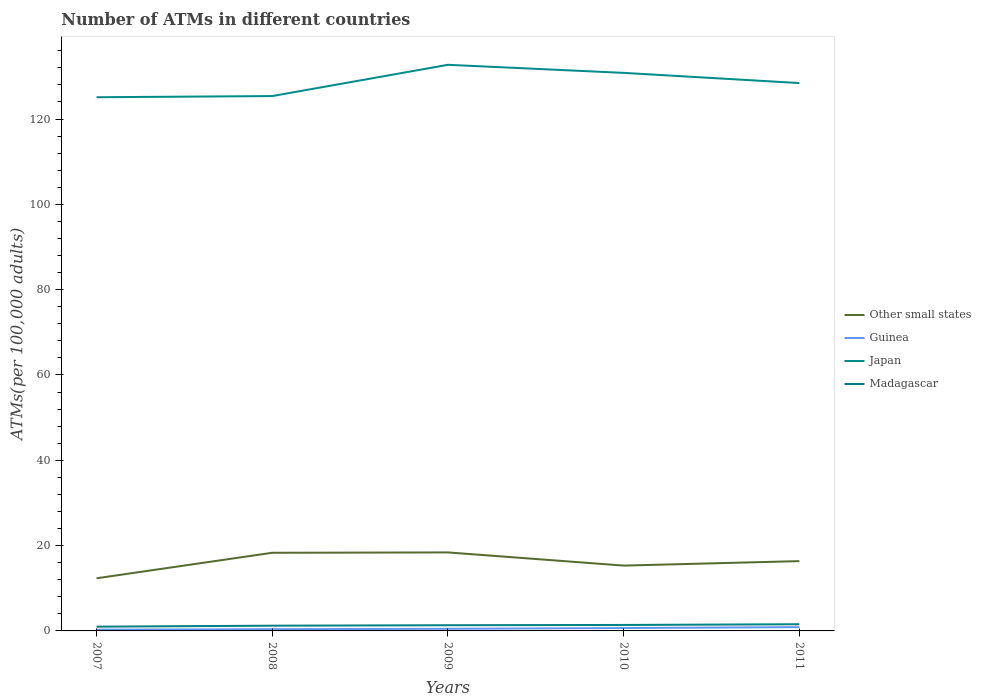How many different coloured lines are there?
Give a very brief answer. 4. Does the line corresponding to Other small states intersect with the line corresponding to Madagascar?
Offer a terse response. No. Across all years, what is the maximum number of ATMs in Other small states?
Provide a succinct answer. 12.34. What is the total number of ATMs in Guinea in the graph?
Offer a terse response. -0.38. What is the difference between the highest and the second highest number of ATMs in Guinea?
Provide a short and direct response. 0.59. What is the difference between two consecutive major ticks on the Y-axis?
Keep it short and to the point. 20. Does the graph contain any zero values?
Offer a terse response. No. Does the graph contain grids?
Give a very brief answer. No. Where does the legend appear in the graph?
Your answer should be very brief. Center right. How many legend labels are there?
Provide a short and direct response. 4. How are the legend labels stacked?
Give a very brief answer. Vertical. What is the title of the graph?
Offer a terse response. Number of ATMs in different countries. What is the label or title of the Y-axis?
Your response must be concise. ATMs(per 100,0 adults). What is the ATMs(per 100,000 adults) of Other small states in 2007?
Your answer should be compact. 12.34. What is the ATMs(per 100,000 adults) in Guinea in 2007?
Your answer should be compact. 0.3. What is the ATMs(per 100,000 adults) of Japan in 2007?
Ensure brevity in your answer.  125.11. What is the ATMs(per 100,000 adults) in Madagascar in 2007?
Give a very brief answer. 1. What is the ATMs(per 100,000 adults) in Other small states in 2008?
Your answer should be very brief. 18.32. What is the ATMs(per 100,000 adults) of Guinea in 2008?
Give a very brief answer. 0.41. What is the ATMs(per 100,000 adults) in Japan in 2008?
Offer a very short reply. 125.39. What is the ATMs(per 100,000 adults) in Madagascar in 2008?
Make the answer very short. 1.23. What is the ATMs(per 100,000 adults) in Other small states in 2009?
Make the answer very short. 18.4. What is the ATMs(per 100,000 adults) of Guinea in 2009?
Keep it short and to the point. 0.5. What is the ATMs(per 100,000 adults) in Japan in 2009?
Your response must be concise. 132.71. What is the ATMs(per 100,000 adults) of Madagascar in 2009?
Give a very brief answer. 1.34. What is the ATMs(per 100,000 adults) of Other small states in 2010?
Ensure brevity in your answer.  15.32. What is the ATMs(per 100,000 adults) in Guinea in 2010?
Your answer should be compact. 0.68. What is the ATMs(per 100,000 adults) in Japan in 2010?
Offer a very short reply. 130.82. What is the ATMs(per 100,000 adults) of Madagascar in 2010?
Make the answer very short. 1.4. What is the ATMs(per 100,000 adults) of Other small states in 2011?
Provide a succinct answer. 16.36. What is the ATMs(per 100,000 adults) in Guinea in 2011?
Provide a succinct answer. 0.89. What is the ATMs(per 100,000 adults) of Japan in 2011?
Provide a short and direct response. 128.44. What is the ATMs(per 100,000 adults) in Madagascar in 2011?
Give a very brief answer. 1.56. Across all years, what is the maximum ATMs(per 100,000 adults) in Other small states?
Your response must be concise. 18.4. Across all years, what is the maximum ATMs(per 100,000 adults) in Guinea?
Ensure brevity in your answer.  0.89. Across all years, what is the maximum ATMs(per 100,000 adults) in Japan?
Your response must be concise. 132.71. Across all years, what is the maximum ATMs(per 100,000 adults) of Madagascar?
Offer a very short reply. 1.56. Across all years, what is the minimum ATMs(per 100,000 adults) in Other small states?
Ensure brevity in your answer.  12.34. Across all years, what is the minimum ATMs(per 100,000 adults) in Guinea?
Keep it short and to the point. 0.3. Across all years, what is the minimum ATMs(per 100,000 adults) of Japan?
Keep it short and to the point. 125.11. Across all years, what is the minimum ATMs(per 100,000 adults) in Madagascar?
Keep it short and to the point. 1. What is the total ATMs(per 100,000 adults) in Other small states in the graph?
Provide a succinct answer. 80.74. What is the total ATMs(per 100,000 adults) in Guinea in the graph?
Ensure brevity in your answer.  2.77. What is the total ATMs(per 100,000 adults) in Japan in the graph?
Ensure brevity in your answer.  642.47. What is the total ATMs(per 100,000 adults) in Madagascar in the graph?
Your answer should be very brief. 6.53. What is the difference between the ATMs(per 100,000 adults) in Other small states in 2007 and that in 2008?
Keep it short and to the point. -5.98. What is the difference between the ATMs(per 100,000 adults) in Guinea in 2007 and that in 2008?
Provide a short and direct response. -0.11. What is the difference between the ATMs(per 100,000 adults) in Japan in 2007 and that in 2008?
Your response must be concise. -0.28. What is the difference between the ATMs(per 100,000 adults) in Madagascar in 2007 and that in 2008?
Your answer should be very brief. -0.23. What is the difference between the ATMs(per 100,000 adults) of Other small states in 2007 and that in 2009?
Provide a short and direct response. -6.06. What is the difference between the ATMs(per 100,000 adults) in Guinea in 2007 and that in 2009?
Provide a short and direct response. -0.2. What is the difference between the ATMs(per 100,000 adults) in Japan in 2007 and that in 2009?
Your answer should be very brief. -7.6. What is the difference between the ATMs(per 100,000 adults) in Madagascar in 2007 and that in 2009?
Offer a very short reply. -0.33. What is the difference between the ATMs(per 100,000 adults) of Other small states in 2007 and that in 2010?
Keep it short and to the point. -2.98. What is the difference between the ATMs(per 100,000 adults) in Guinea in 2007 and that in 2010?
Your answer should be compact. -0.38. What is the difference between the ATMs(per 100,000 adults) in Japan in 2007 and that in 2010?
Make the answer very short. -5.71. What is the difference between the ATMs(per 100,000 adults) in Madagascar in 2007 and that in 2010?
Give a very brief answer. -0.4. What is the difference between the ATMs(per 100,000 adults) in Other small states in 2007 and that in 2011?
Ensure brevity in your answer.  -4.02. What is the difference between the ATMs(per 100,000 adults) in Guinea in 2007 and that in 2011?
Provide a short and direct response. -0.59. What is the difference between the ATMs(per 100,000 adults) of Japan in 2007 and that in 2011?
Offer a very short reply. -3.32. What is the difference between the ATMs(per 100,000 adults) in Madagascar in 2007 and that in 2011?
Give a very brief answer. -0.56. What is the difference between the ATMs(per 100,000 adults) in Other small states in 2008 and that in 2009?
Provide a succinct answer. -0.08. What is the difference between the ATMs(per 100,000 adults) in Guinea in 2008 and that in 2009?
Provide a short and direct response. -0.09. What is the difference between the ATMs(per 100,000 adults) in Japan in 2008 and that in 2009?
Give a very brief answer. -7.32. What is the difference between the ATMs(per 100,000 adults) of Madagascar in 2008 and that in 2009?
Your response must be concise. -0.11. What is the difference between the ATMs(per 100,000 adults) of Other small states in 2008 and that in 2010?
Your answer should be very brief. 3. What is the difference between the ATMs(per 100,000 adults) of Guinea in 2008 and that in 2010?
Offer a very short reply. -0.27. What is the difference between the ATMs(per 100,000 adults) in Japan in 2008 and that in 2010?
Give a very brief answer. -5.44. What is the difference between the ATMs(per 100,000 adults) in Madagascar in 2008 and that in 2010?
Ensure brevity in your answer.  -0.17. What is the difference between the ATMs(per 100,000 adults) in Other small states in 2008 and that in 2011?
Ensure brevity in your answer.  1.96. What is the difference between the ATMs(per 100,000 adults) in Guinea in 2008 and that in 2011?
Make the answer very short. -0.48. What is the difference between the ATMs(per 100,000 adults) in Japan in 2008 and that in 2011?
Keep it short and to the point. -3.05. What is the difference between the ATMs(per 100,000 adults) of Madagascar in 2008 and that in 2011?
Provide a short and direct response. -0.34. What is the difference between the ATMs(per 100,000 adults) in Other small states in 2009 and that in 2010?
Make the answer very short. 3.09. What is the difference between the ATMs(per 100,000 adults) of Guinea in 2009 and that in 2010?
Make the answer very short. -0.18. What is the difference between the ATMs(per 100,000 adults) of Japan in 2009 and that in 2010?
Give a very brief answer. 1.89. What is the difference between the ATMs(per 100,000 adults) in Madagascar in 2009 and that in 2010?
Provide a succinct answer. -0.06. What is the difference between the ATMs(per 100,000 adults) of Other small states in 2009 and that in 2011?
Provide a short and direct response. 2.04. What is the difference between the ATMs(per 100,000 adults) of Guinea in 2009 and that in 2011?
Give a very brief answer. -0.39. What is the difference between the ATMs(per 100,000 adults) of Japan in 2009 and that in 2011?
Provide a short and direct response. 4.28. What is the difference between the ATMs(per 100,000 adults) of Madagascar in 2009 and that in 2011?
Make the answer very short. -0.23. What is the difference between the ATMs(per 100,000 adults) of Other small states in 2010 and that in 2011?
Offer a very short reply. -1.05. What is the difference between the ATMs(per 100,000 adults) in Guinea in 2010 and that in 2011?
Provide a short and direct response. -0.21. What is the difference between the ATMs(per 100,000 adults) of Japan in 2010 and that in 2011?
Give a very brief answer. 2.39. What is the difference between the ATMs(per 100,000 adults) of Madagascar in 2010 and that in 2011?
Give a very brief answer. -0.16. What is the difference between the ATMs(per 100,000 adults) in Other small states in 2007 and the ATMs(per 100,000 adults) in Guinea in 2008?
Your response must be concise. 11.93. What is the difference between the ATMs(per 100,000 adults) of Other small states in 2007 and the ATMs(per 100,000 adults) of Japan in 2008?
Keep it short and to the point. -113.05. What is the difference between the ATMs(per 100,000 adults) of Other small states in 2007 and the ATMs(per 100,000 adults) of Madagascar in 2008?
Offer a terse response. 11.11. What is the difference between the ATMs(per 100,000 adults) in Guinea in 2007 and the ATMs(per 100,000 adults) in Japan in 2008?
Your answer should be compact. -125.09. What is the difference between the ATMs(per 100,000 adults) in Guinea in 2007 and the ATMs(per 100,000 adults) in Madagascar in 2008?
Provide a succinct answer. -0.93. What is the difference between the ATMs(per 100,000 adults) of Japan in 2007 and the ATMs(per 100,000 adults) of Madagascar in 2008?
Provide a succinct answer. 123.88. What is the difference between the ATMs(per 100,000 adults) in Other small states in 2007 and the ATMs(per 100,000 adults) in Guinea in 2009?
Make the answer very short. 11.84. What is the difference between the ATMs(per 100,000 adults) of Other small states in 2007 and the ATMs(per 100,000 adults) of Japan in 2009?
Keep it short and to the point. -120.37. What is the difference between the ATMs(per 100,000 adults) of Other small states in 2007 and the ATMs(per 100,000 adults) of Madagascar in 2009?
Offer a very short reply. 11.01. What is the difference between the ATMs(per 100,000 adults) of Guinea in 2007 and the ATMs(per 100,000 adults) of Japan in 2009?
Provide a succinct answer. -132.41. What is the difference between the ATMs(per 100,000 adults) of Guinea in 2007 and the ATMs(per 100,000 adults) of Madagascar in 2009?
Ensure brevity in your answer.  -1.04. What is the difference between the ATMs(per 100,000 adults) in Japan in 2007 and the ATMs(per 100,000 adults) in Madagascar in 2009?
Offer a very short reply. 123.78. What is the difference between the ATMs(per 100,000 adults) in Other small states in 2007 and the ATMs(per 100,000 adults) in Guinea in 2010?
Ensure brevity in your answer.  11.67. What is the difference between the ATMs(per 100,000 adults) of Other small states in 2007 and the ATMs(per 100,000 adults) of Japan in 2010?
Make the answer very short. -118.48. What is the difference between the ATMs(per 100,000 adults) of Other small states in 2007 and the ATMs(per 100,000 adults) of Madagascar in 2010?
Provide a short and direct response. 10.94. What is the difference between the ATMs(per 100,000 adults) of Guinea in 2007 and the ATMs(per 100,000 adults) of Japan in 2010?
Provide a succinct answer. -130.53. What is the difference between the ATMs(per 100,000 adults) in Guinea in 2007 and the ATMs(per 100,000 adults) in Madagascar in 2010?
Make the answer very short. -1.1. What is the difference between the ATMs(per 100,000 adults) of Japan in 2007 and the ATMs(per 100,000 adults) of Madagascar in 2010?
Your response must be concise. 123.71. What is the difference between the ATMs(per 100,000 adults) of Other small states in 2007 and the ATMs(per 100,000 adults) of Guinea in 2011?
Make the answer very short. 11.45. What is the difference between the ATMs(per 100,000 adults) of Other small states in 2007 and the ATMs(per 100,000 adults) of Japan in 2011?
Give a very brief answer. -116.1. What is the difference between the ATMs(per 100,000 adults) in Other small states in 2007 and the ATMs(per 100,000 adults) in Madagascar in 2011?
Offer a very short reply. 10.78. What is the difference between the ATMs(per 100,000 adults) of Guinea in 2007 and the ATMs(per 100,000 adults) of Japan in 2011?
Make the answer very short. -128.14. What is the difference between the ATMs(per 100,000 adults) of Guinea in 2007 and the ATMs(per 100,000 adults) of Madagascar in 2011?
Your response must be concise. -1.27. What is the difference between the ATMs(per 100,000 adults) in Japan in 2007 and the ATMs(per 100,000 adults) in Madagascar in 2011?
Offer a very short reply. 123.55. What is the difference between the ATMs(per 100,000 adults) in Other small states in 2008 and the ATMs(per 100,000 adults) in Guinea in 2009?
Your answer should be compact. 17.82. What is the difference between the ATMs(per 100,000 adults) in Other small states in 2008 and the ATMs(per 100,000 adults) in Japan in 2009?
Keep it short and to the point. -114.39. What is the difference between the ATMs(per 100,000 adults) of Other small states in 2008 and the ATMs(per 100,000 adults) of Madagascar in 2009?
Your answer should be compact. 16.98. What is the difference between the ATMs(per 100,000 adults) in Guinea in 2008 and the ATMs(per 100,000 adults) in Japan in 2009?
Make the answer very short. -132.3. What is the difference between the ATMs(per 100,000 adults) of Guinea in 2008 and the ATMs(per 100,000 adults) of Madagascar in 2009?
Give a very brief answer. -0.93. What is the difference between the ATMs(per 100,000 adults) in Japan in 2008 and the ATMs(per 100,000 adults) in Madagascar in 2009?
Offer a very short reply. 124.05. What is the difference between the ATMs(per 100,000 adults) in Other small states in 2008 and the ATMs(per 100,000 adults) in Guinea in 2010?
Your response must be concise. 17.64. What is the difference between the ATMs(per 100,000 adults) in Other small states in 2008 and the ATMs(per 100,000 adults) in Japan in 2010?
Offer a very short reply. -112.5. What is the difference between the ATMs(per 100,000 adults) in Other small states in 2008 and the ATMs(per 100,000 adults) in Madagascar in 2010?
Offer a very short reply. 16.92. What is the difference between the ATMs(per 100,000 adults) of Guinea in 2008 and the ATMs(per 100,000 adults) of Japan in 2010?
Provide a short and direct response. -130.41. What is the difference between the ATMs(per 100,000 adults) of Guinea in 2008 and the ATMs(per 100,000 adults) of Madagascar in 2010?
Ensure brevity in your answer.  -0.99. What is the difference between the ATMs(per 100,000 adults) in Japan in 2008 and the ATMs(per 100,000 adults) in Madagascar in 2010?
Provide a short and direct response. 123.99. What is the difference between the ATMs(per 100,000 adults) of Other small states in 2008 and the ATMs(per 100,000 adults) of Guinea in 2011?
Provide a succinct answer. 17.43. What is the difference between the ATMs(per 100,000 adults) in Other small states in 2008 and the ATMs(per 100,000 adults) in Japan in 2011?
Ensure brevity in your answer.  -110.12. What is the difference between the ATMs(per 100,000 adults) in Other small states in 2008 and the ATMs(per 100,000 adults) in Madagascar in 2011?
Offer a terse response. 16.76. What is the difference between the ATMs(per 100,000 adults) in Guinea in 2008 and the ATMs(per 100,000 adults) in Japan in 2011?
Make the answer very short. -128.03. What is the difference between the ATMs(per 100,000 adults) in Guinea in 2008 and the ATMs(per 100,000 adults) in Madagascar in 2011?
Provide a succinct answer. -1.15. What is the difference between the ATMs(per 100,000 adults) in Japan in 2008 and the ATMs(per 100,000 adults) in Madagascar in 2011?
Keep it short and to the point. 123.82. What is the difference between the ATMs(per 100,000 adults) in Other small states in 2009 and the ATMs(per 100,000 adults) in Guinea in 2010?
Provide a succinct answer. 17.73. What is the difference between the ATMs(per 100,000 adults) of Other small states in 2009 and the ATMs(per 100,000 adults) of Japan in 2010?
Your answer should be compact. -112.42. What is the difference between the ATMs(per 100,000 adults) of Other small states in 2009 and the ATMs(per 100,000 adults) of Madagascar in 2010?
Offer a terse response. 17. What is the difference between the ATMs(per 100,000 adults) of Guinea in 2009 and the ATMs(per 100,000 adults) of Japan in 2010?
Offer a terse response. -130.33. What is the difference between the ATMs(per 100,000 adults) of Guinea in 2009 and the ATMs(per 100,000 adults) of Madagascar in 2010?
Offer a terse response. -0.9. What is the difference between the ATMs(per 100,000 adults) of Japan in 2009 and the ATMs(per 100,000 adults) of Madagascar in 2010?
Your answer should be compact. 131.31. What is the difference between the ATMs(per 100,000 adults) in Other small states in 2009 and the ATMs(per 100,000 adults) in Guinea in 2011?
Your answer should be compact. 17.51. What is the difference between the ATMs(per 100,000 adults) of Other small states in 2009 and the ATMs(per 100,000 adults) of Japan in 2011?
Give a very brief answer. -110.03. What is the difference between the ATMs(per 100,000 adults) in Other small states in 2009 and the ATMs(per 100,000 adults) in Madagascar in 2011?
Your response must be concise. 16.84. What is the difference between the ATMs(per 100,000 adults) in Guinea in 2009 and the ATMs(per 100,000 adults) in Japan in 2011?
Keep it short and to the point. -127.94. What is the difference between the ATMs(per 100,000 adults) of Guinea in 2009 and the ATMs(per 100,000 adults) of Madagascar in 2011?
Provide a short and direct response. -1.07. What is the difference between the ATMs(per 100,000 adults) in Japan in 2009 and the ATMs(per 100,000 adults) in Madagascar in 2011?
Give a very brief answer. 131.15. What is the difference between the ATMs(per 100,000 adults) in Other small states in 2010 and the ATMs(per 100,000 adults) in Guinea in 2011?
Your response must be concise. 14.43. What is the difference between the ATMs(per 100,000 adults) in Other small states in 2010 and the ATMs(per 100,000 adults) in Japan in 2011?
Provide a short and direct response. -113.12. What is the difference between the ATMs(per 100,000 adults) in Other small states in 2010 and the ATMs(per 100,000 adults) in Madagascar in 2011?
Your response must be concise. 13.75. What is the difference between the ATMs(per 100,000 adults) in Guinea in 2010 and the ATMs(per 100,000 adults) in Japan in 2011?
Provide a succinct answer. -127.76. What is the difference between the ATMs(per 100,000 adults) of Guinea in 2010 and the ATMs(per 100,000 adults) of Madagascar in 2011?
Make the answer very short. -0.89. What is the difference between the ATMs(per 100,000 adults) of Japan in 2010 and the ATMs(per 100,000 adults) of Madagascar in 2011?
Offer a very short reply. 129.26. What is the average ATMs(per 100,000 adults) of Other small states per year?
Your answer should be very brief. 16.15. What is the average ATMs(per 100,000 adults) of Guinea per year?
Make the answer very short. 0.55. What is the average ATMs(per 100,000 adults) in Japan per year?
Offer a terse response. 128.49. What is the average ATMs(per 100,000 adults) in Madagascar per year?
Offer a terse response. 1.31. In the year 2007, what is the difference between the ATMs(per 100,000 adults) of Other small states and ATMs(per 100,000 adults) of Guinea?
Your answer should be very brief. 12.04. In the year 2007, what is the difference between the ATMs(per 100,000 adults) of Other small states and ATMs(per 100,000 adults) of Japan?
Keep it short and to the point. -112.77. In the year 2007, what is the difference between the ATMs(per 100,000 adults) in Other small states and ATMs(per 100,000 adults) in Madagascar?
Ensure brevity in your answer.  11.34. In the year 2007, what is the difference between the ATMs(per 100,000 adults) of Guinea and ATMs(per 100,000 adults) of Japan?
Your answer should be very brief. -124.81. In the year 2007, what is the difference between the ATMs(per 100,000 adults) in Guinea and ATMs(per 100,000 adults) in Madagascar?
Ensure brevity in your answer.  -0.7. In the year 2007, what is the difference between the ATMs(per 100,000 adults) of Japan and ATMs(per 100,000 adults) of Madagascar?
Make the answer very short. 124.11. In the year 2008, what is the difference between the ATMs(per 100,000 adults) of Other small states and ATMs(per 100,000 adults) of Guinea?
Give a very brief answer. 17.91. In the year 2008, what is the difference between the ATMs(per 100,000 adults) in Other small states and ATMs(per 100,000 adults) in Japan?
Provide a succinct answer. -107.07. In the year 2008, what is the difference between the ATMs(per 100,000 adults) in Other small states and ATMs(per 100,000 adults) in Madagascar?
Offer a terse response. 17.09. In the year 2008, what is the difference between the ATMs(per 100,000 adults) in Guinea and ATMs(per 100,000 adults) in Japan?
Make the answer very short. -124.98. In the year 2008, what is the difference between the ATMs(per 100,000 adults) of Guinea and ATMs(per 100,000 adults) of Madagascar?
Your response must be concise. -0.82. In the year 2008, what is the difference between the ATMs(per 100,000 adults) of Japan and ATMs(per 100,000 adults) of Madagascar?
Make the answer very short. 124.16. In the year 2009, what is the difference between the ATMs(per 100,000 adults) of Other small states and ATMs(per 100,000 adults) of Guinea?
Offer a very short reply. 17.91. In the year 2009, what is the difference between the ATMs(per 100,000 adults) in Other small states and ATMs(per 100,000 adults) in Japan?
Give a very brief answer. -114.31. In the year 2009, what is the difference between the ATMs(per 100,000 adults) of Other small states and ATMs(per 100,000 adults) of Madagascar?
Ensure brevity in your answer.  17.07. In the year 2009, what is the difference between the ATMs(per 100,000 adults) in Guinea and ATMs(per 100,000 adults) in Japan?
Provide a succinct answer. -132.22. In the year 2009, what is the difference between the ATMs(per 100,000 adults) of Guinea and ATMs(per 100,000 adults) of Madagascar?
Make the answer very short. -0.84. In the year 2009, what is the difference between the ATMs(per 100,000 adults) of Japan and ATMs(per 100,000 adults) of Madagascar?
Your answer should be very brief. 131.38. In the year 2010, what is the difference between the ATMs(per 100,000 adults) of Other small states and ATMs(per 100,000 adults) of Guinea?
Give a very brief answer. 14.64. In the year 2010, what is the difference between the ATMs(per 100,000 adults) in Other small states and ATMs(per 100,000 adults) in Japan?
Provide a succinct answer. -115.51. In the year 2010, what is the difference between the ATMs(per 100,000 adults) of Other small states and ATMs(per 100,000 adults) of Madagascar?
Provide a succinct answer. 13.92. In the year 2010, what is the difference between the ATMs(per 100,000 adults) in Guinea and ATMs(per 100,000 adults) in Japan?
Your response must be concise. -130.15. In the year 2010, what is the difference between the ATMs(per 100,000 adults) of Guinea and ATMs(per 100,000 adults) of Madagascar?
Provide a succinct answer. -0.72. In the year 2010, what is the difference between the ATMs(per 100,000 adults) in Japan and ATMs(per 100,000 adults) in Madagascar?
Your answer should be very brief. 129.42. In the year 2011, what is the difference between the ATMs(per 100,000 adults) in Other small states and ATMs(per 100,000 adults) in Guinea?
Provide a succinct answer. 15.47. In the year 2011, what is the difference between the ATMs(per 100,000 adults) in Other small states and ATMs(per 100,000 adults) in Japan?
Offer a very short reply. -112.07. In the year 2011, what is the difference between the ATMs(per 100,000 adults) in Other small states and ATMs(per 100,000 adults) in Madagascar?
Your answer should be compact. 14.8. In the year 2011, what is the difference between the ATMs(per 100,000 adults) in Guinea and ATMs(per 100,000 adults) in Japan?
Provide a short and direct response. -127.55. In the year 2011, what is the difference between the ATMs(per 100,000 adults) in Guinea and ATMs(per 100,000 adults) in Madagascar?
Your answer should be compact. -0.67. In the year 2011, what is the difference between the ATMs(per 100,000 adults) in Japan and ATMs(per 100,000 adults) in Madagascar?
Your answer should be very brief. 126.87. What is the ratio of the ATMs(per 100,000 adults) of Other small states in 2007 to that in 2008?
Make the answer very short. 0.67. What is the ratio of the ATMs(per 100,000 adults) in Guinea in 2007 to that in 2008?
Your answer should be compact. 0.73. What is the ratio of the ATMs(per 100,000 adults) of Madagascar in 2007 to that in 2008?
Provide a succinct answer. 0.81. What is the ratio of the ATMs(per 100,000 adults) in Other small states in 2007 to that in 2009?
Your answer should be very brief. 0.67. What is the ratio of the ATMs(per 100,000 adults) of Guinea in 2007 to that in 2009?
Make the answer very short. 0.6. What is the ratio of the ATMs(per 100,000 adults) of Japan in 2007 to that in 2009?
Your answer should be very brief. 0.94. What is the ratio of the ATMs(per 100,000 adults) of Madagascar in 2007 to that in 2009?
Your answer should be compact. 0.75. What is the ratio of the ATMs(per 100,000 adults) in Other small states in 2007 to that in 2010?
Offer a terse response. 0.81. What is the ratio of the ATMs(per 100,000 adults) in Guinea in 2007 to that in 2010?
Keep it short and to the point. 0.44. What is the ratio of the ATMs(per 100,000 adults) in Japan in 2007 to that in 2010?
Your response must be concise. 0.96. What is the ratio of the ATMs(per 100,000 adults) in Madagascar in 2007 to that in 2010?
Give a very brief answer. 0.72. What is the ratio of the ATMs(per 100,000 adults) of Other small states in 2007 to that in 2011?
Give a very brief answer. 0.75. What is the ratio of the ATMs(per 100,000 adults) of Guinea in 2007 to that in 2011?
Ensure brevity in your answer.  0.34. What is the ratio of the ATMs(per 100,000 adults) in Japan in 2007 to that in 2011?
Ensure brevity in your answer.  0.97. What is the ratio of the ATMs(per 100,000 adults) of Madagascar in 2007 to that in 2011?
Ensure brevity in your answer.  0.64. What is the ratio of the ATMs(per 100,000 adults) in Guinea in 2008 to that in 2009?
Make the answer very short. 0.82. What is the ratio of the ATMs(per 100,000 adults) of Japan in 2008 to that in 2009?
Your answer should be very brief. 0.94. What is the ratio of the ATMs(per 100,000 adults) of Other small states in 2008 to that in 2010?
Your answer should be compact. 1.2. What is the ratio of the ATMs(per 100,000 adults) in Guinea in 2008 to that in 2010?
Make the answer very short. 0.61. What is the ratio of the ATMs(per 100,000 adults) in Japan in 2008 to that in 2010?
Offer a very short reply. 0.96. What is the ratio of the ATMs(per 100,000 adults) in Madagascar in 2008 to that in 2010?
Your answer should be compact. 0.88. What is the ratio of the ATMs(per 100,000 adults) in Other small states in 2008 to that in 2011?
Offer a terse response. 1.12. What is the ratio of the ATMs(per 100,000 adults) in Guinea in 2008 to that in 2011?
Make the answer very short. 0.46. What is the ratio of the ATMs(per 100,000 adults) of Japan in 2008 to that in 2011?
Keep it short and to the point. 0.98. What is the ratio of the ATMs(per 100,000 adults) of Madagascar in 2008 to that in 2011?
Your response must be concise. 0.79. What is the ratio of the ATMs(per 100,000 adults) in Other small states in 2009 to that in 2010?
Give a very brief answer. 1.2. What is the ratio of the ATMs(per 100,000 adults) of Guinea in 2009 to that in 2010?
Your answer should be very brief. 0.74. What is the ratio of the ATMs(per 100,000 adults) of Japan in 2009 to that in 2010?
Ensure brevity in your answer.  1.01. What is the ratio of the ATMs(per 100,000 adults) in Madagascar in 2009 to that in 2010?
Your answer should be compact. 0.95. What is the ratio of the ATMs(per 100,000 adults) of Other small states in 2009 to that in 2011?
Your response must be concise. 1.12. What is the ratio of the ATMs(per 100,000 adults) of Guinea in 2009 to that in 2011?
Provide a short and direct response. 0.56. What is the ratio of the ATMs(per 100,000 adults) in Madagascar in 2009 to that in 2011?
Offer a very short reply. 0.85. What is the ratio of the ATMs(per 100,000 adults) of Other small states in 2010 to that in 2011?
Ensure brevity in your answer.  0.94. What is the ratio of the ATMs(per 100,000 adults) of Guinea in 2010 to that in 2011?
Your answer should be very brief. 0.76. What is the ratio of the ATMs(per 100,000 adults) in Japan in 2010 to that in 2011?
Your answer should be compact. 1.02. What is the ratio of the ATMs(per 100,000 adults) in Madagascar in 2010 to that in 2011?
Offer a very short reply. 0.9. What is the difference between the highest and the second highest ATMs(per 100,000 adults) of Other small states?
Offer a terse response. 0.08. What is the difference between the highest and the second highest ATMs(per 100,000 adults) in Guinea?
Give a very brief answer. 0.21. What is the difference between the highest and the second highest ATMs(per 100,000 adults) of Japan?
Offer a very short reply. 1.89. What is the difference between the highest and the second highest ATMs(per 100,000 adults) of Madagascar?
Provide a succinct answer. 0.16. What is the difference between the highest and the lowest ATMs(per 100,000 adults) in Other small states?
Keep it short and to the point. 6.06. What is the difference between the highest and the lowest ATMs(per 100,000 adults) of Guinea?
Provide a short and direct response. 0.59. What is the difference between the highest and the lowest ATMs(per 100,000 adults) of Japan?
Your answer should be compact. 7.6. What is the difference between the highest and the lowest ATMs(per 100,000 adults) in Madagascar?
Your response must be concise. 0.56. 